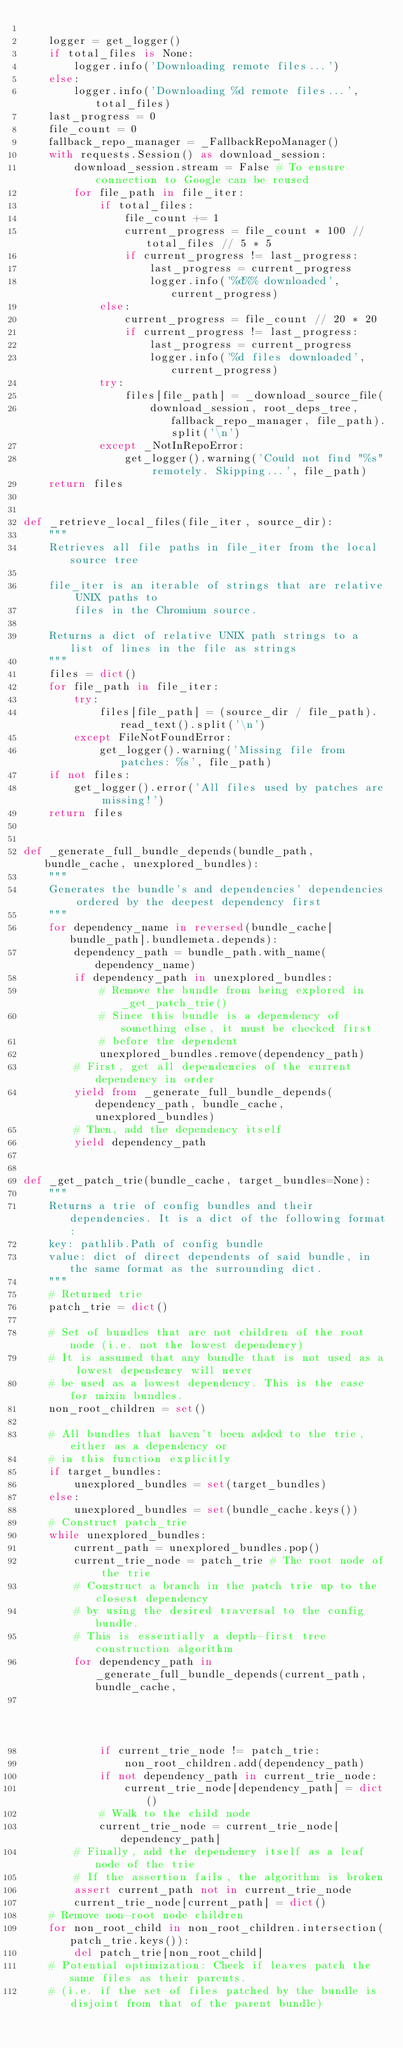<code> <loc_0><loc_0><loc_500><loc_500><_Python_>
    logger = get_logger()
    if total_files is None:
        logger.info('Downloading remote files...')
    else:
        logger.info('Downloading %d remote files...', total_files)
    last_progress = 0
    file_count = 0
    fallback_repo_manager = _FallbackRepoManager()
    with requests.Session() as download_session:
        download_session.stream = False # To ensure connection to Google can be reused
        for file_path in file_iter:
            if total_files:
                file_count += 1
                current_progress = file_count * 100 // total_files // 5 * 5
                if current_progress != last_progress:
                    last_progress = current_progress
                    logger.info('%d%% downloaded', current_progress)
            else:
                current_progress = file_count // 20 * 20
                if current_progress != last_progress:
                    last_progress = current_progress
                    logger.info('%d files downloaded', current_progress)
            try:
                files[file_path] = _download_source_file(
                    download_session, root_deps_tree, fallback_repo_manager, file_path).split('\n')
            except _NotInRepoError:
                get_logger().warning('Could not find "%s" remotely. Skipping...', file_path)
    return files


def _retrieve_local_files(file_iter, source_dir):
    """
    Retrieves all file paths in file_iter from the local source tree

    file_iter is an iterable of strings that are relative UNIX paths to
        files in the Chromium source.

    Returns a dict of relative UNIX path strings to a list of lines in the file as strings
    """
    files = dict()
    for file_path in file_iter:
        try:
            files[file_path] = (source_dir / file_path).read_text().split('\n')
        except FileNotFoundError:
            get_logger().warning('Missing file from patches: %s', file_path)
    if not files:
        get_logger().error('All files used by patches are missing!')
    return files


def _generate_full_bundle_depends(bundle_path, bundle_cache, unexplored_bundles):
    """
    Generates the bundle's and dependencies' dependencies ordered by the deepest dependency first
    """
    for dependency_name in reversed(bundle_cache[bundle_path].bundlemeta.depends):
        dependency_path = bundle_path.with_name(dependency_name)
        if dependency_path in unexplored_bundles:
            # Remove the bundle from being explored in _get_patch_trie()
            # Since this bundle is a dependency of something else, it must be checked first
            # before the dependent
            unexplored_bundles.remove(dependency_path)
        # First, get all dependencies of the current dependency in order
        yield from _generate_full_bundle_depends(dependency_path, bundle_cache, unexplored_bundles)
        # Then, add the dependency itself
        yield dependency_path


def _get_patch_trie(bundle_cache, target_bundles=None):
    """
    Returns a trie of config bundles and their dependencies. It is a dict of the following format:
    key: pathlib.Path of config bundle
    value: dict of direct dependents of said bundle, in the same format as the surrounding dict.
    """
    # Returned trie
    patch_trie = dict()

    # Set of bundles that are not children of the root node (i.e. not the lowest dependency)
    # It is assumed that any bundle that is not used as a lowest dependency will never
    # be used as a lowest dependency. This is the case for mixin bundles.
    non_root_children = set()

    # All bundles that haven't been added to the trie, either as a dependency or
    # in this function explicitly
    if target_bundles:
        unexplored_bundles = set(target_bundles)
    else:
        unexplored_bundles = set(bundle_cache.keys())
    # Construct patch_trie
    while unexplored_bundles:
        current_path = unexplored_bundles.pop()
        current_trie_node = patch_trie # The root node of the trie
        # Construct a branch in the patch trie up to the closest dependency
        # by using the desired traversal to the config bundle.
        # This is essentially a depth-first tree construction algorithm
        for dependency_path in _generate_full_bundle_depends(current_path, bundle_cache,
                                                             unexplored_bundles):
            if current_trie_node != patch_trie:
                non_root_children.add(dependency_path)
            if not dependency_path in current_trie_node:
                current_trie_node[dependency_path] = dict()
            # Walk to the child node
            current_trie_node = current_trie_node[dependency_path]
        # Finally, add the dependency itself as a leaf node of the trie
        # If the assertion fails, the algorithm is broken
        assert current_path not in current_trie_node
        current_trie_node[current_path] = dict()
    # Remove non-root node children
    for non_root_child in non_root_children.intersection(patch_trie.keys()):
        del patch_trie[non_root_child]
    # Potential optimization: Check if leaves patch the same files as their parents.
    # (i.e. if the set of files patched by the bundle is disjoint from that of the parent bundle)</code> 